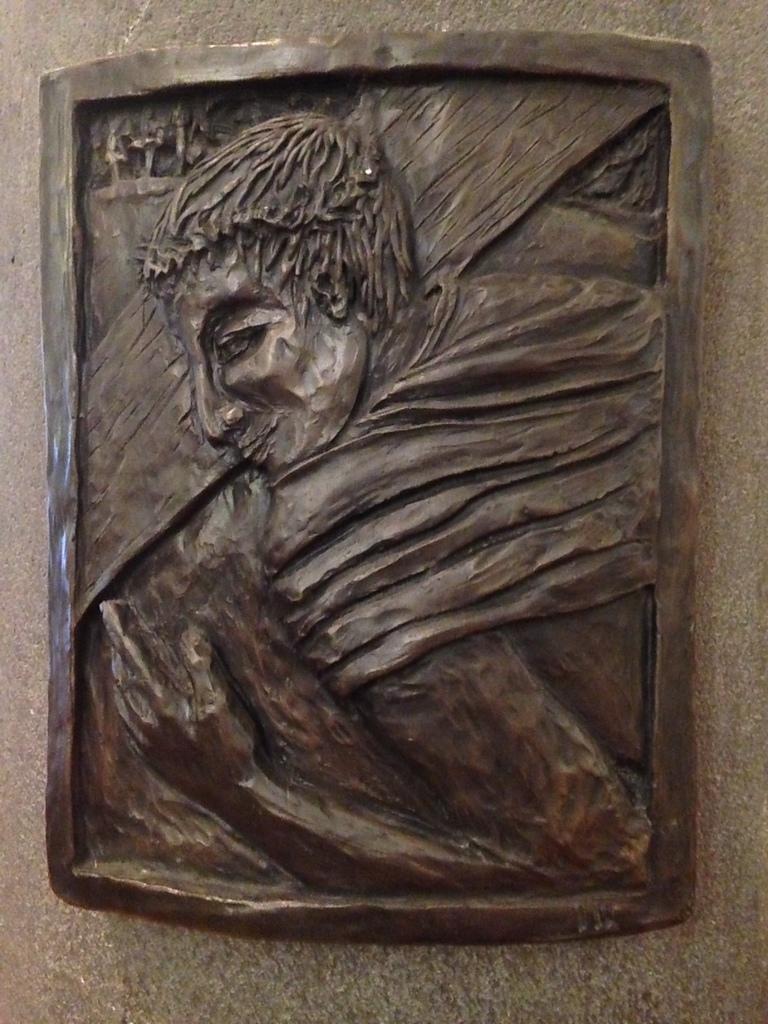Can you describe this image briefly? In the center of the image we can see a sculpture on the wall. 